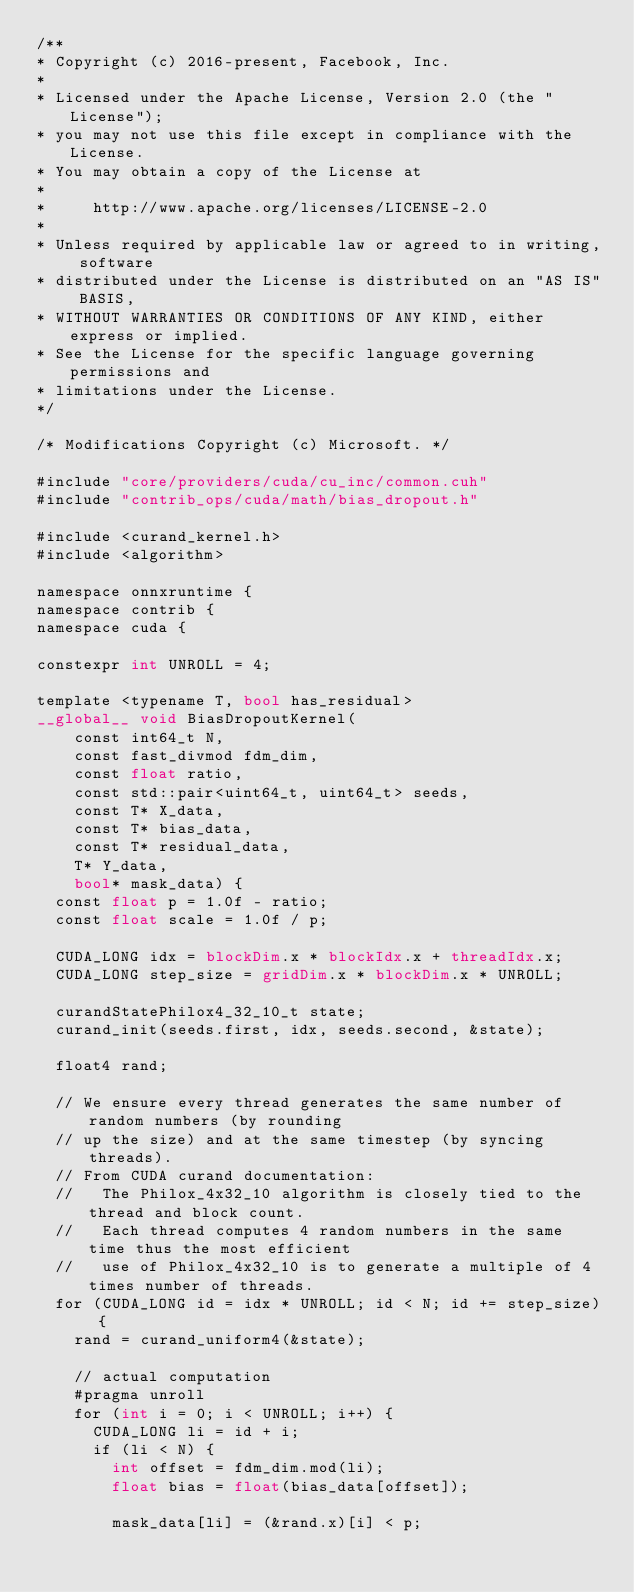<code> <loc_0><loc_0><loc_500><loc_500><_Cuda_>/**
* Copyright (c) 2016-present, Facebook, Inc.
*
* Licensed under the Apache License, Version 2.0 (the "License");
* you may not use this file except in compliance with the License.
* You may obtain a copy of the License at
*
*     http://www.apache.org/licenses/LICENSE-2.0
*
* Unless required by applicable law or agreed to in writing, software
* distributed under the License is distributed on an "AS IS" BASIS,
* WITHOUT WARRANTIES OR CONDITIONS OF ANY KIND, either express or implied.
* See the License for the specific language governing permissions and
* limitations under the License.
*/

/* Modifications Copyright (c) Microsoft. */

#include "core/providers/cuda/cu_inc/common.cuh"
#include "contrib_ops/cuda/math/bias_dropout.h"

#include <curand_kernel.h>
#include <algorithm>

namespace onnxruntime {
namespace contrib {
namespace cuda {

constexpr int UNROLL = 4;

template <typename T, bool has_residual>
__global__ void BiasDropoutKernel(
    const int64_t N,
    const fast_divmod fdm_dim,
    const float ratio,
    const std::pair<uint64_t, uint64_t> seeds,
    const T* X_data,
    const T* bias_data,
    const T* residual_data,
    T* Y_data,
    bool* mask_data) {
  const float p = 1.0f - ratio;
  const float scale = 1.0f / p;

  CUDA_LONG idx = blockDim.x * blockIdx.x + threadIdx.x;
  CUDA_LONG step_size = gridDim.x * blockDim.x * UNROLL;

  curandStatePhilox4_32_10_t state;
  curand_init(seeds.first, idx, seeds.second, &state);

  float4 rand;

  // We ensure every thread generates the same number of random numbers (by rounding
  // up the size) and at the same timestep (by syncing threads).
  // From CUDA curand documentation:
  //   The Philox_4x32_10 algorithm is closely tied to the thread and block count.
  //   Each thread computes 4 random numbers in the same time thus the most efficient
  //   use of Philox_4x32_10 is to generate a multiple of 4 times number of threads.
  for (CUDA_LONG id = idx * UNROLL; id < N; id += step_size) {
    rand = curand_uniform4(&state);
  
    // actual computation
    #pragma unroll
    for (int i = 0; i < UNROLL; i++) {
      CUDA_LONG li = id + i;
      if (li < N) {
        int offset = fdm_dim.mod(li);
        float bias = float(bias_data[offset]);

        mask_data[li] = (&rand.x)[i] < p;</code> 